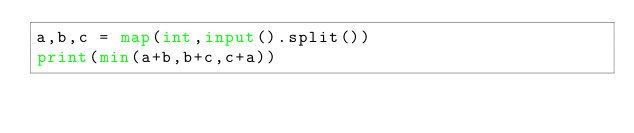<code> <loc_0><loc_0><loc_500><loc_500><_Python_>a,b,c = map(int,input().split())
print(min(a+b,b+c,c+a))
        </code> 